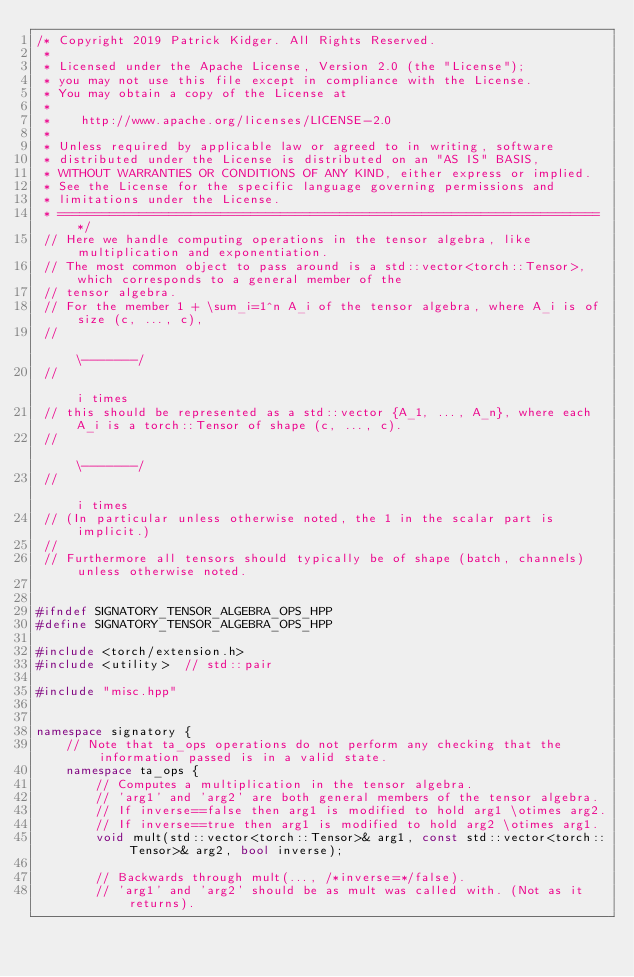<code> <loc_0><loc_0><loc_500><loc_500><_C++_>/* Copyright 2019 Patrick Kidger. All Rights Reserved.
 *
 * Licensed under the Apache License, Version 2.0 (the "License");
 * you may not use this file except in compliance with the License.
 * You may obtain a copy of the License at
 * 
 *    http://www.apache.org/licenses/LICENSE-2.0
 * 
 * Unless required by applicable law or agreed to in writing, software
 * distributed under the License is distributed on an "AS IS" BASIS,
 * WITHOUT WARRANTIES OR CONDITIONS OF ANY KIND, either express or implied.
 * See the License for the specific language governing permissions and
 * limitations under the License.
 * ========================================================================= */
 // Here we handle computing operations in the tensor algebra, like multiplication and exponentiation.
 // The most common object to pass around is a std::vector<torch::Tensor>, which corresponds to a general member of the
 // tensor algebra.
 // For the member 1 + \sum_i=1^n A_i of the tensor algebra, where A_i is of size (c, ..., c),
 //                                                                                \-------/
 //                                                                                 i times
 // this should be represented as a std::vector {A_1, ..., A_n}, where each A_i is a torch::Tensor of shape (c, ..., c).
 //                                                                                                          \-------/
 //                                                                                                           i times
 // (In particular unless otherwise noted, the 1 in the scalar part is implicit.)
 //
 // Furthermore all tensors should typically be of shape (batch, channels) unless otherwise noted.


#ifndef SIGNATORY_TENSOR_ALGEBRA_OPS_HPP
#define SIGNATORY_TENSOR_ALGEBRA_OPS_HPP

#include <torch/extension.h>
#include <utility>  // std::pair

#include "misc.hpp"


namespace signatory {
    // Note that ta_ops operations do not perform any checking that the information passed is in a valid state.
    namespace ta_ops {
        // Computes a multiplication in the tensor algebra.
        // 'arg1' and 'arg2' are both general members of the tensor algebra.
        // If inverse==false then arg1 is modified to hold arg1 \otimes arg2.
        // If inverse==true then arg1 is modified to hold arg2 \otimes arg1.
        void mult(std::vector<torch::Tensor>& arg1, const std::vector<torch::Tensor>& arg2, bool inverse);

        // Backwards through mult(..., /*inverse=*/false).
        // 'arg1' and 'arg2' should be as mult was called with. (Not as it returns).</code> 